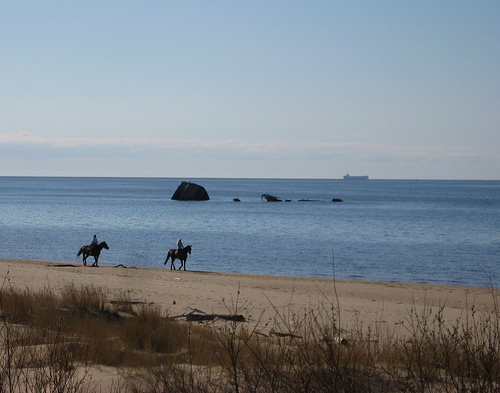How does this setting affect the mood of the picture? The serene setting, with the vast ocean and clear sky, imparts a sense of tranquility and isolation. The presence of the horseback riders adds a touch of peaceful motion and suggests a connection with nature. The absence of any crowded elements or busy human activities further emphasizes the calming and restorative mood conveyed by the image. 